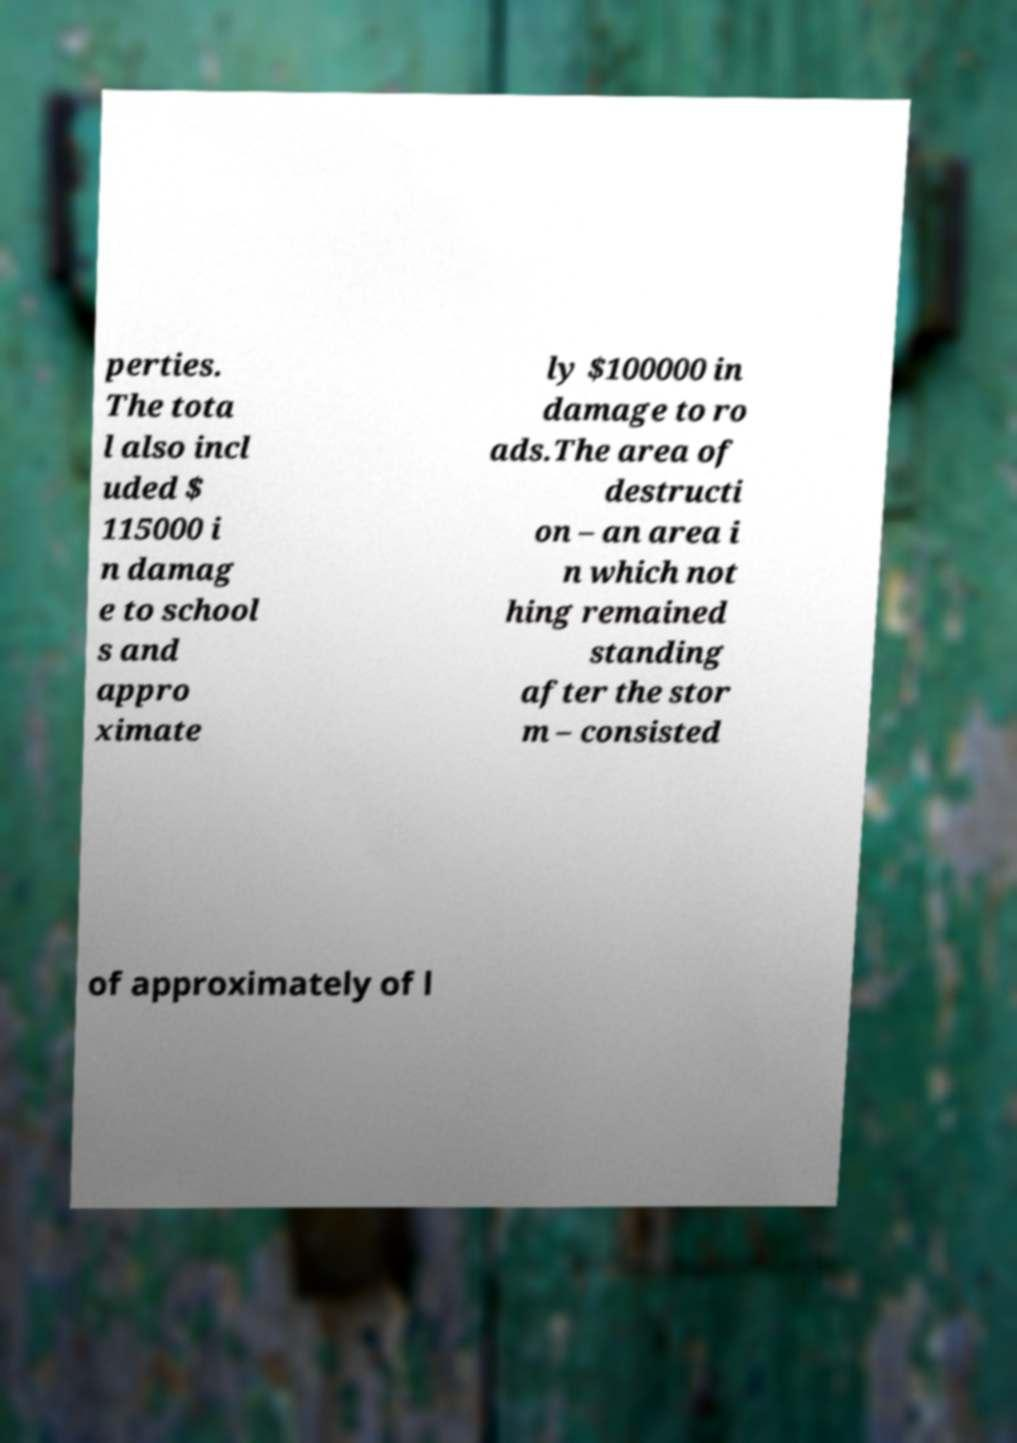I need the written content from this picture converted into text. Can you do that? perties. The tota l also incl uded $ 115000 i n damag e to school s and appro ximate ly $100000 in damage to ro ads.The area of destructi on – an area i n which not hing remained standing after the stor m – consisted of approximately of l 